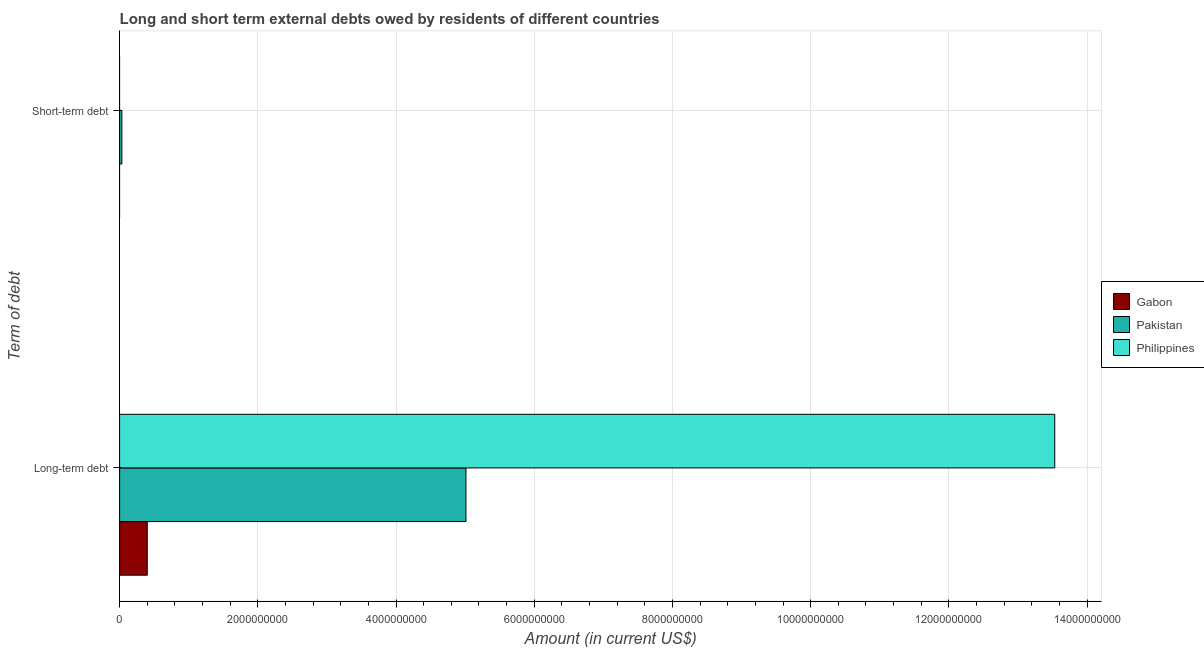Are the number of bars per tick equal to the number of legend labels?
Make the answer very short. No. How many bars are there on the 2nd tick from the bottom?
Your answer should be very brief. 1. What is the label of the 1st group of bars from the top?
Your answer should be very brief. Short-term debt. What is the long-term debts owed by residents in Philippines?
Make the answer very short. 1.35e+1. Across all countries, what is the maximum short-term debts owed by residents?
Keep it short and to the point. 3.26e+07. Across all countries, what is the minimum short-term debts owed by residents?
Make the answer very short. 0. In which country was the short-term debts owed by residents maximum?
Your answer should be compact. Pakistan. What is the total long-term debts owed by residents in the graph?
Your answer should be compact. 1.89e+1. What is the difference between the long-term debts owed by residents in Gabon and that in Philippines?
Ensure brevity in your answer.  -1.31e+1. What is the difference between the short-term debts owed by residents in Gabon and the long-term debts owed by residents in Philippines?
Give a very brief answer. -1.35e+1. What is the average short-term debts owed by residents per country?
Offer a very short reply. 1.09e+07. What is the difference between the long-term debts owed by residents and short-term debts owed by residents in Pakistan?
Offer a very short reply. 4.98e+09. In how many countries, is the long-term debts owed by residents greater than 2800000000 US$?
Your answer should be compact. 2. What is the ratio of the long-term debts owed by residents in Philippines to that in Gabon?
Keep it short and to the point. 33.84. How many countries are there in the graph?
Provide a succinct answer. 3. What is the difference between two consecutive major ticks on the X-axis?
Make the answer very short. 2.00e+09. Are the values on the major ticks of X-axis written in scientific E-notation?
Your answer should be compact. No. Does the graph contain grids?
Your answer should be very brief. Yes. How many legend labels are there?
Your answer should be very brief. 3. How are the legend labels stacked?
Your answer should be compact. Vertical. What is the title of the graph?
Provide a succinct answer. Long and short term external debts owed by residents of different countries. What is the label or title of the X-axis?
Offer a very short reply. Amount (in current US$). What is the label or title of the Y-axis?
Provide a short and direct response. Term of debt. What is the Amount (in current US$) of Gabon in Long-term debt?
Ensure brevity in your answer.  4.00e+08. What is the Amount (in current US$) in Pakistan in Long-term debt?
Offer a very short reply. 5.01e+09. What is the Amount (in current US$) in Philippines in Long-term debt?
Give a very brief answer. 1.35e+1. What is the Amount (in current US$) in Pakistan in Short-term debt?
Offer a terse response. 3.26e+07. What is the Amount (in current US$) in Philippines in Short-term debt?
Ensure brevity in your answer.  0. Across all Term of debt, what is the maximum Amount (in current US$) in Gabon?
Give a very brief answer. 4.00e+08. Across all Term of debt, what is the maximum Amount (in current US$) of Pakistan?
Provide a short and direct response. 5.01e+09. Across all Term of debt, what is the maximum Amount (in current US$) of Philippines?
Offer a very short reply. 1.35e+1. Across all Term of debt, what is the minimum Amount (in current US$) of Gabon?
Offer a terse response. 0. Across all Term of debt, what is the minimum Amount (in current US$) of Pakistan?
Offer a terse response. 3.26e+07. Across all Term of debt, what is the minimum Amount (in current US$) in Philippines?
Offer a terse response. 0. What is the total Amount (in current US$) of Gabon in the graph?
Keep it short and to the point. 4.00e+08. What is the total Amount (in current US$) of Pakistan in the graph?
Offer a terse response. 5.04e+09. What is the total Amount (in current US$) in Philippines in the graph?
Your answer should be compact. 1.35e+1. What is the difference between the Amount (in current US$) in Pakistan in Long-term debt and that in Short-term debt?
Your response must be concise. 4.98e+09. What is the difference between the Amount (in current US$) in Gabon in Long-term debt and the Amount (in current US$) in Pakistan in Short-term debt?
Make the answer very short. 3.67e+08. What is the average Amount (in current US$) of Gabon per Term of debt?
Provide a succinct answer. 2.00e+08. What is the average Amount (in current US$) in Pakistan per Term of debt?
Ensure brevity in your answer.  2.52e+09. What is the average Amount (in current US$) in Philippines per Term of debt?
Your answer should be very brief. 6.77e+09. What is the difference between the Amount (in current US$) of Gabon and Amount (in current US$) of Pakistan in Long-term debt?
Ensure brevity in your answer.  -4.61e+09. What is the difference between the Amount (in current US$) in Gabon and Amount (in current US$) in Philippines in Long-term debt?
Ensure brevity in your answer.  -1.31e+1. What is the difference between the Amount (in current US$) of Pakistan and Amount (in current US$) of Philippines in Long-term debt?
Offer a terse response. -8.52e+09. What is the ratio of the Amount (in current US$) of Pakistan in Long-term debt to that in Short-term debt?
Provide a short and direct response. 153.58. What is the difference between the highest and the second highest Amount (in current US$) in Pakistan?
Your answer should be very brief. 4.98e+09. What is the difference between the highest and the lowest Amount (in current US$) of Gabon?
Your answer should be compact. 4.00e+08. What is the difference between the highest and the lowest Amount (in current US$) in Pakistan?
Ensure brevity in your answer.  4.98e+09. What is the difference between the highest and the lowest Amount (in current US$) of Philippines?
Your response must be concise. 1.35e+1. 